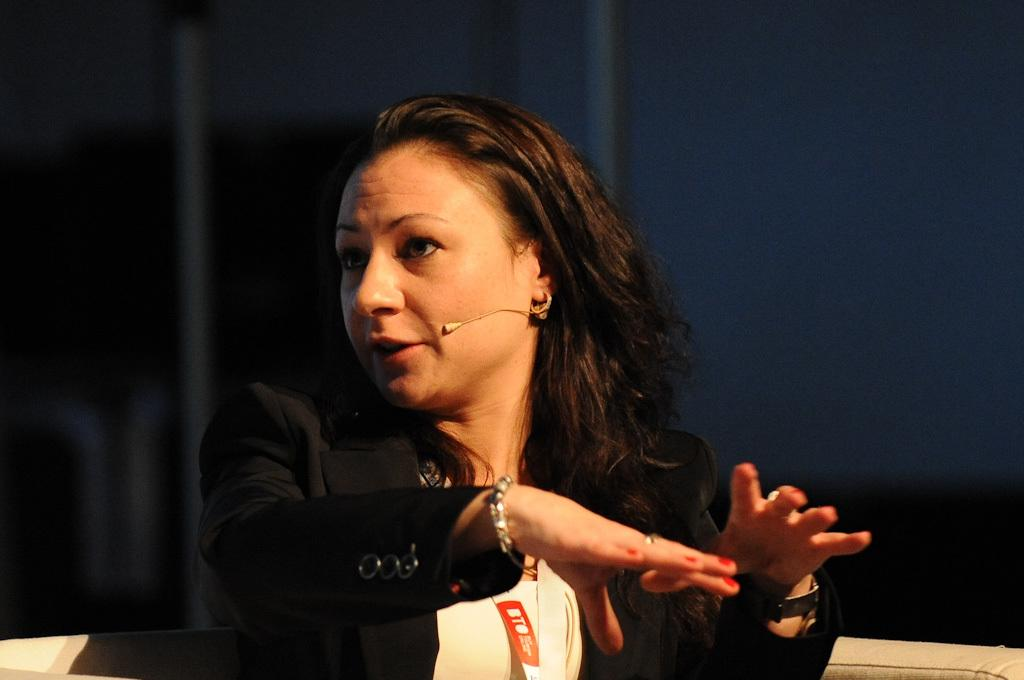Who is present in the image? There is a woman in the image. What is the woman wearing? The woman is wearing a coat. Where is the woman sitting? The woman is sitting on a sofa. What object is also on the sofa? There is a microphone on the sofa. What can be seen in the background of the image? There are curtains in the background of the image. What type of salt is sprinkled on the sofa in the image? There is no salt present in the image; it features a woman sitting on a sofa with a microphone. 